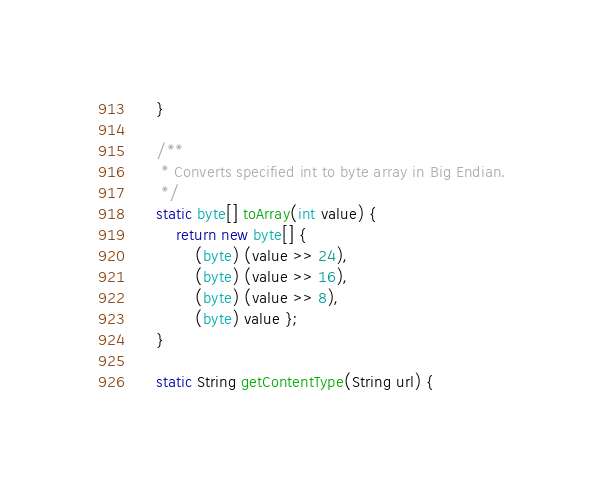<code> <loc_0><loc_0><loc_500><loc_500><_Java_>    }

    /**
     * Converts specified int to byte array in Big Endian.
     */
    static byte[] toArray(int value) {
        return new byte[] {
            (byte) (value >> 24),
            (byte) (value >> 16),
            (byte) (value >> 8),
            (byte) value };
    }

    static String getContentType(String url) {</code> 